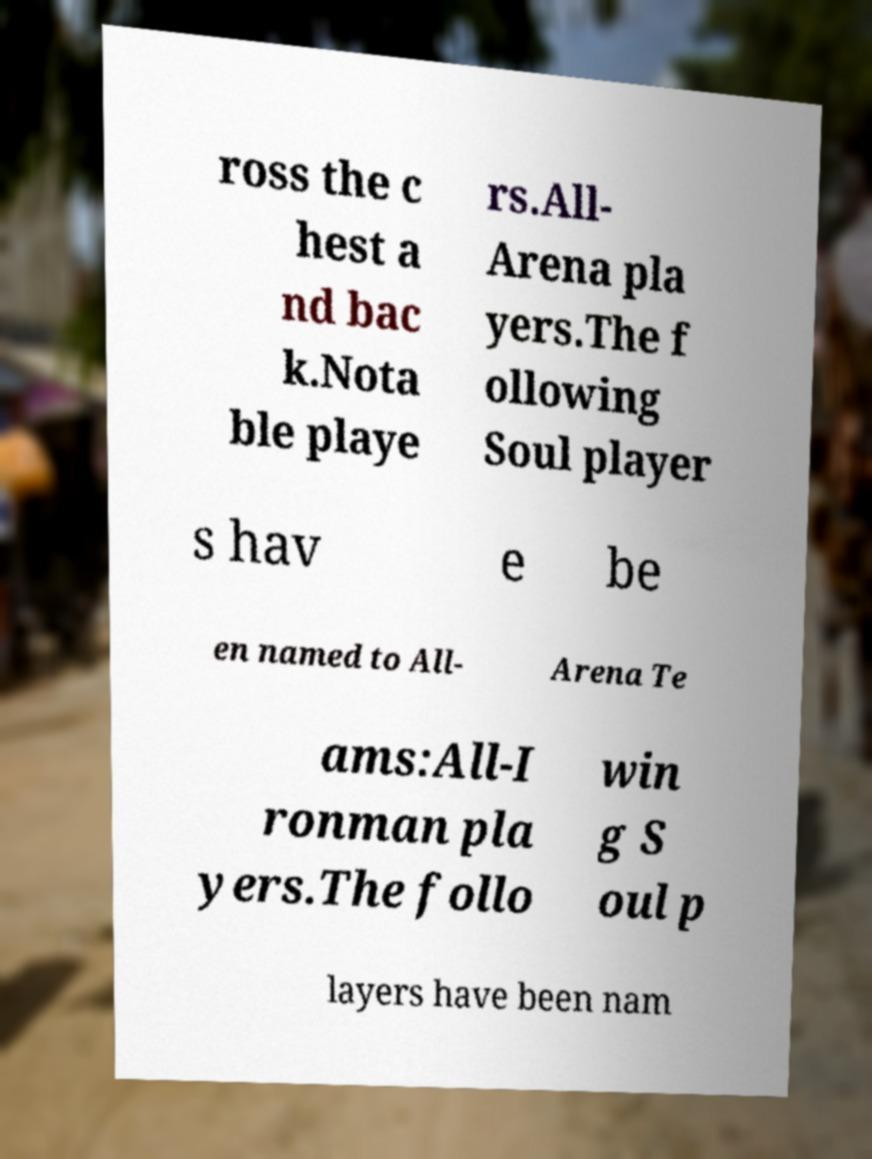There's text embedded in this image that I need extracted. Can you transcribe it verbatim? ross the c hest a nd bac k.Nota ble playe rs.All- Arena pla yers.The f ollowing Soul player s hav e be en named to All- Arena Te ams:All-I ronman pla yers.The follo win g S oul p layers have been nam 